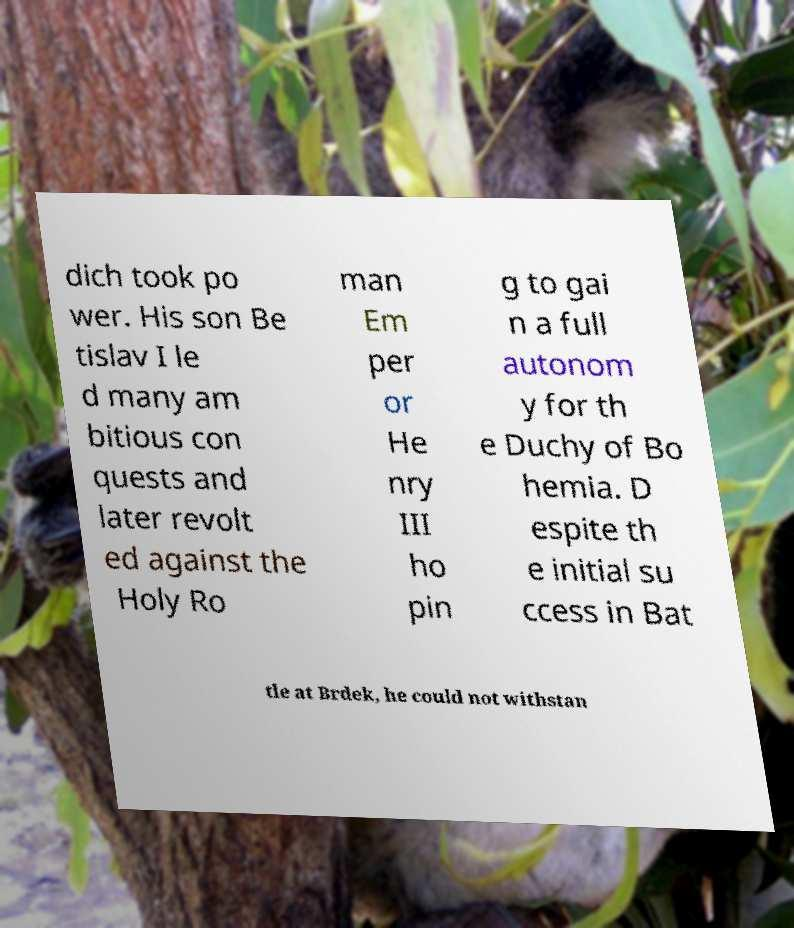I need the written content from this picture converted into text. Can you do that? dich took po wer. His son Be tislav I le d many am bitious con quests and later revolt ed against the Holy Ro man Em per or He nry III ho pin g to gai n a full autonom y for th e Duchy of Bo hemia. D espite th e initial su ccess in Bat tle at Brdek, he could not withstan 